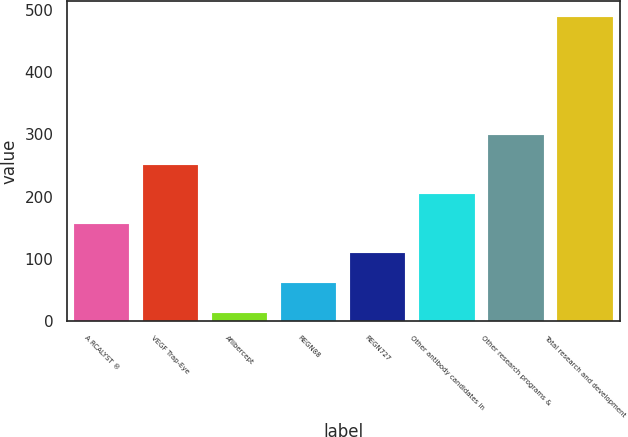Convert chart. <chart><loc_0><loc_0><loc_500><loc_500><bar_chart><fcel>A RCALYST ®<fcel>VEGF Trap-Eye<fcel>Aflibercept<fcel>REGN88<fcel>REGN727<fcel>Other antibody candidates in<fcel>Other research programs &<fcel>Total research and development<nl><fcel>156.21<fcel>251.35<fcel>13.5<fcel>61.07<fcel>108.64<fcel>203.78<fcel>298.92<fcel>489.2<nl></chart> 